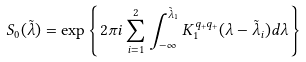<formula> <loc_0><loc_0><loc_500><loc_500>S _ { 0 } ( \tilde { \lambda } ) = \exp \left \{ 2 \pi i \sum _ { i = 1 } ^ { 2 } \int _ { - \infty } ^ { \tilde { \lambda } _ { 1 } } K _ { 1 } ^ { q _ { + } q _ { + } } ( \lambda - \tilde { \lambda } _ { i } ) d \lambda \right \}</formula> 